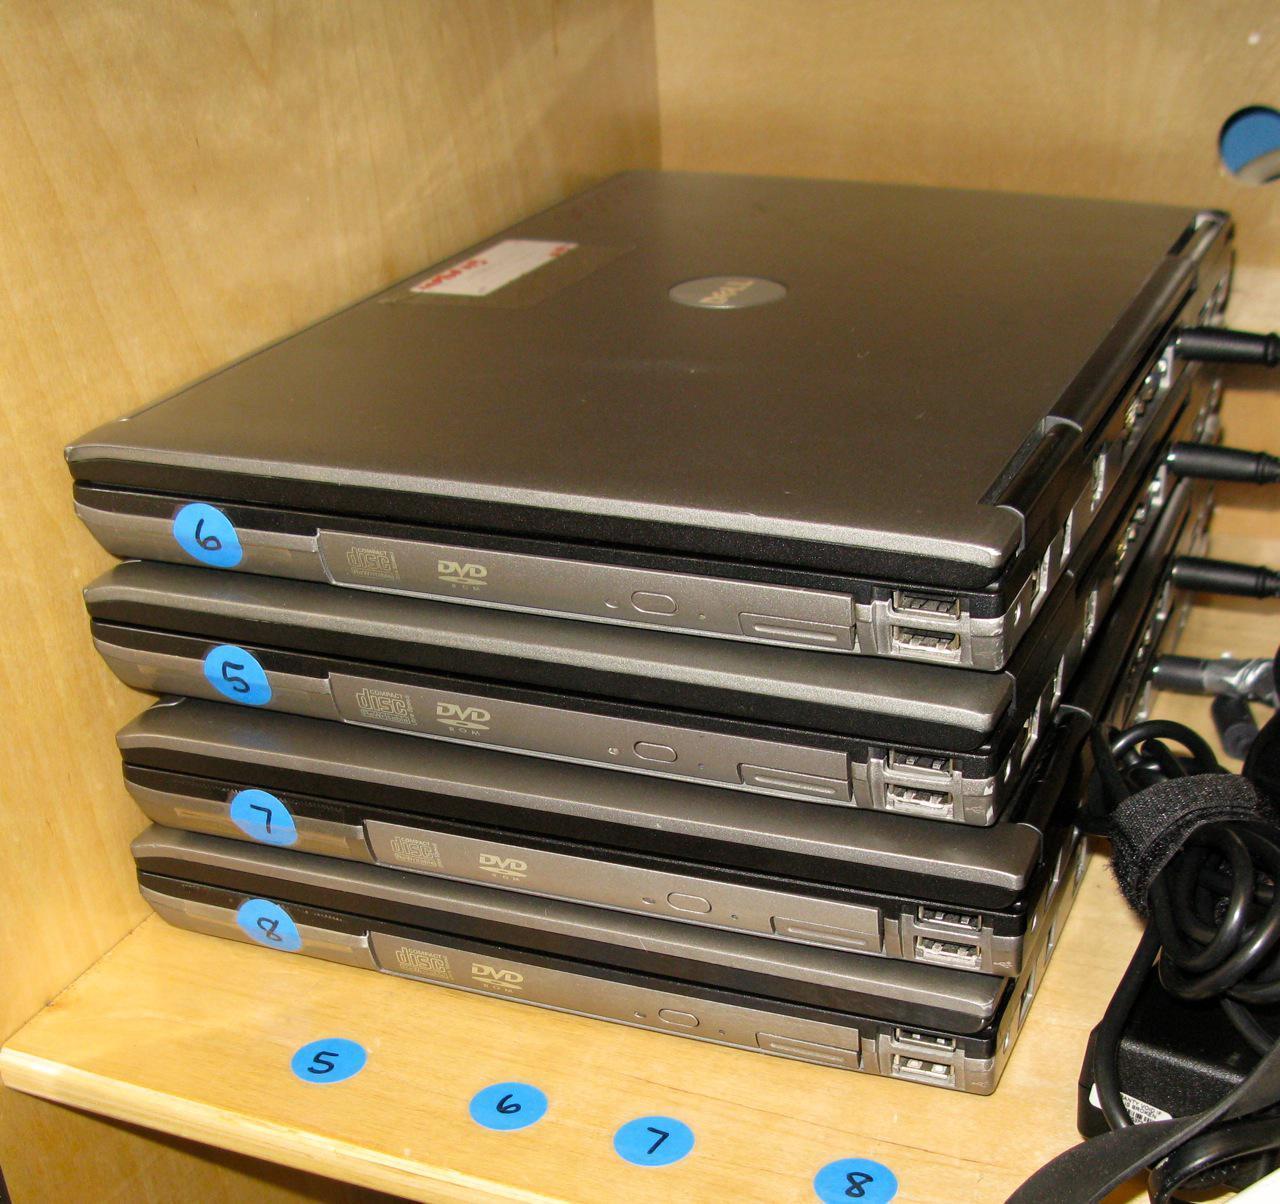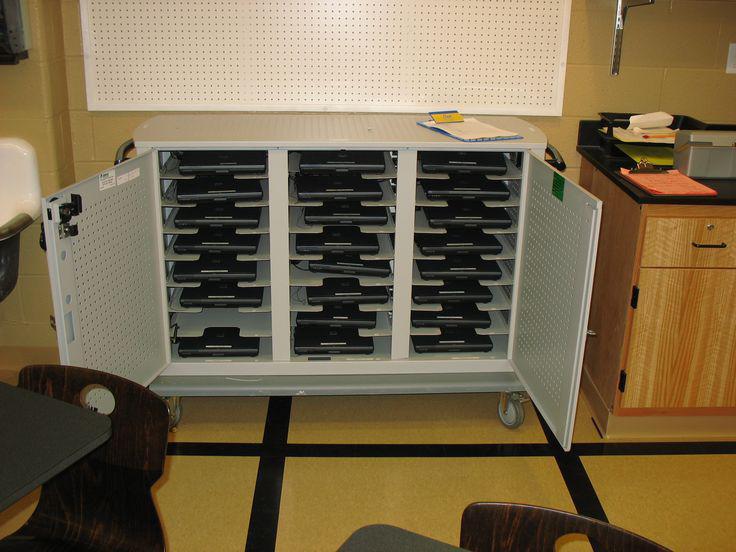The first image is the image on the left, the second image is the image on the right. Examine the images to the left and right. Is the description "One image shows laptops stacked directly on top of each other, and the other image shows a shelved unit that stores laptops horizontally in multiple rows." accurate? Answer yes or no. Yes. The first image is the image on the left, the second image is the image on the right. Analyze the images presented: Is the assertion "All of the computers are sitting flat." valid? Answer yes or no. Yes. 